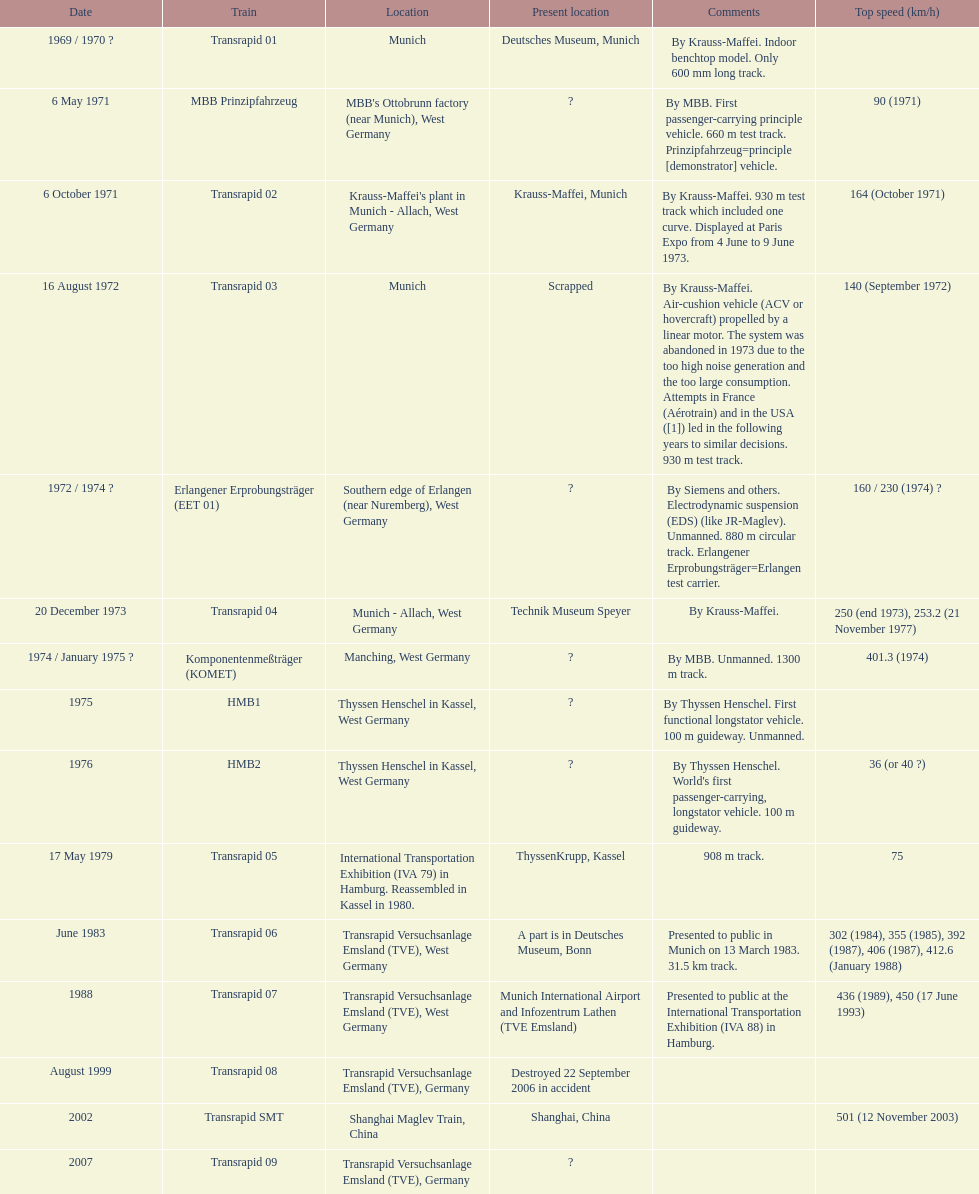Could you parse the entire table? {'header': ['Date', 'Train', 'Location', 'Present location', 'Comments', 'Top speed (km/h)'], 'rows': [['1969 / 1970\xa0?', 'Transrapid 01', 'Munich', 'Deutsches Museum, Munich', 'By Krauss-Maffei. Indoor benchtop model. Only 600\xa0mm long track.', ''], ['6 May 1971', 'MBB Prinzipfahrzeug', "MBB's Ottobrunn factory (near Munich), West Germany", '?', 'By MBB. First passenger-carrying principle vehicle. 660 m test track. Prinzipfahrzeug=principle [demonstrator] vehicle.', '90 (1971)'], ['6 October 1971', 'Transrapid 02', "Krauss-Maffei's plant in Munich - Allach, West Germany", 'Krauss-Maffei, Munich', 'By Krauss-Maffei. 930 m test track which included one curve. Displayed at Paris Expo from 4 June to 9 June 1973.', '164 (October 1971)'], ['16 August 1972', 'Transrapid 03', 'Munich', 'Scrapped', 'By Krauss-Maffei. Air-cushion vehicle (ACV or hovercraft) propelled by a linear motor. The system was abandoned in 1973 due to the too high noise generation and the too large consumption. Attempts in France (Aérotrain) and in the USA ([1]) led in the following years to similar decisions. 930 m test track.', '140 (September 1972)'], ['1972 / 1974\xa0?', 'Erlangener Erprobungsträger (EET 01)', 'Southern edge of Erlangen (near Nuremberg), West Germany', '?', 'By Siemens and others. Electrodynamic suspension (EDS) (like JR-Maglev). Unmanned. 880 m circular track. Erlangener Erprobungsträger=Erlangen test carrier.', '160 / 230 (1974)\xa0?'], ['20 December 1973', 'Transrapid 04', 'Munich - Allach, West Germany', 'Technik Museum Speyer', 'By Krauss-Maffei.', '250 (end 1973), 253.2 (21 November 1977)'], ['1974 / January 1975\xa0?', 'Komponentenmeßträger (KOMET)', 'Manching, West Germany', '?', 'By MBB. Unmanned. 1300 m track.', '401.3 (1974)'], ['1975', 'HMB1', 'Thyssen Henschel in Kassel, West Germany', '?', 'By Thyssen Henschel. First functional longstator vehicle. 100 m guideway. Unmanned.', ''], ['1976', 'HMB2', 'Thyssen Henschel in Kassel, West Germany', '?', "By Thyssen Henschel. World's first passenger-carrying, longstator vehicle. 100 m guideway.", '36 (or 40\xa0?)'], ['17 May 1979', 'Transrapid 05', 'International Transportation Exhibition (IVA 79) in Hamburg. Reassembled in Kassel in 1980.', 'ThyssenKrupp, Kassel', '908 m track.', '75'], ['June 1983', 'Transrapid 06', 'Transrapid Versuchsanlage Emsland (TVE), West Germany', 'A part is in Deutsches Museum, Bonn', 'Presented to public in Munich on 13 March 1983. 31.5\xa0km track.', '302 (1984), 355 (1985), 392 (1987), 406 (1987), 412.6 (January 1988)'], ['1988', 'Transrapid 07', 'Transrapid Versuchsanlage Emsland (TVE), West Germany', 'Munich International Airport and Infozentrum Lathen (TVE Emsland)', 'Presented to public at the International Transportation Exhibition (IVA 88) in Hamburg.', '436 (1989), 450 (17 June 1993)'], ['August 1999', 'Transrapid 08', 'Transrapid Versuchsanlage Emsland (TVE), Germany', 'Destroyed 22 September 2006 in accident', '', ''], ['2002', 'Transrapid SMT', 'Shanghai Maglev Train, China', 'Shanghai, China', '', '501 (12 November 2003)'], ['2007', 'Transrapid 09', 'Transrapid Versuchsanlage Emsland (TVE), Germany', '?', '', '']]} What train was created following the erlangener erprobungsträger? Transrapid 04. 